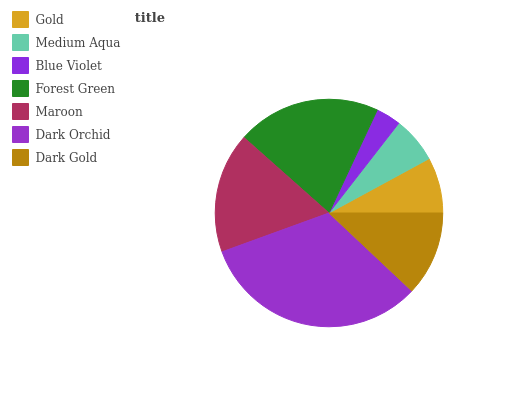Is Blue Violet the minimum?
Answer yes or no. Yes. Is Dark Orchid the maximum?
Answer yes or no. Yes. Is Medium Aqua the minimum?
Answer yes or no. No. Is Medium Aqua the maximum?
Answer yes or no. No. Is Gold greater than Medium Aqua?
Answer yes or no. Yes. Is Medium Aqua less than Gold?
Answer yes or no. Yes. Is Medium Aqua greater than Gold?
Answer yes or no. No. Is Gold less than Medium Aqua?
Answer yes or no. No. Is Dark Gold the high median?
Answer yes or no. Yes. Is Dark Gold the low median?
Answer yes or no. Yes. Is Medium Aqua the high median?
Answer yes or no. No. Is Maroon the low median?
Answer yes or no. No. 